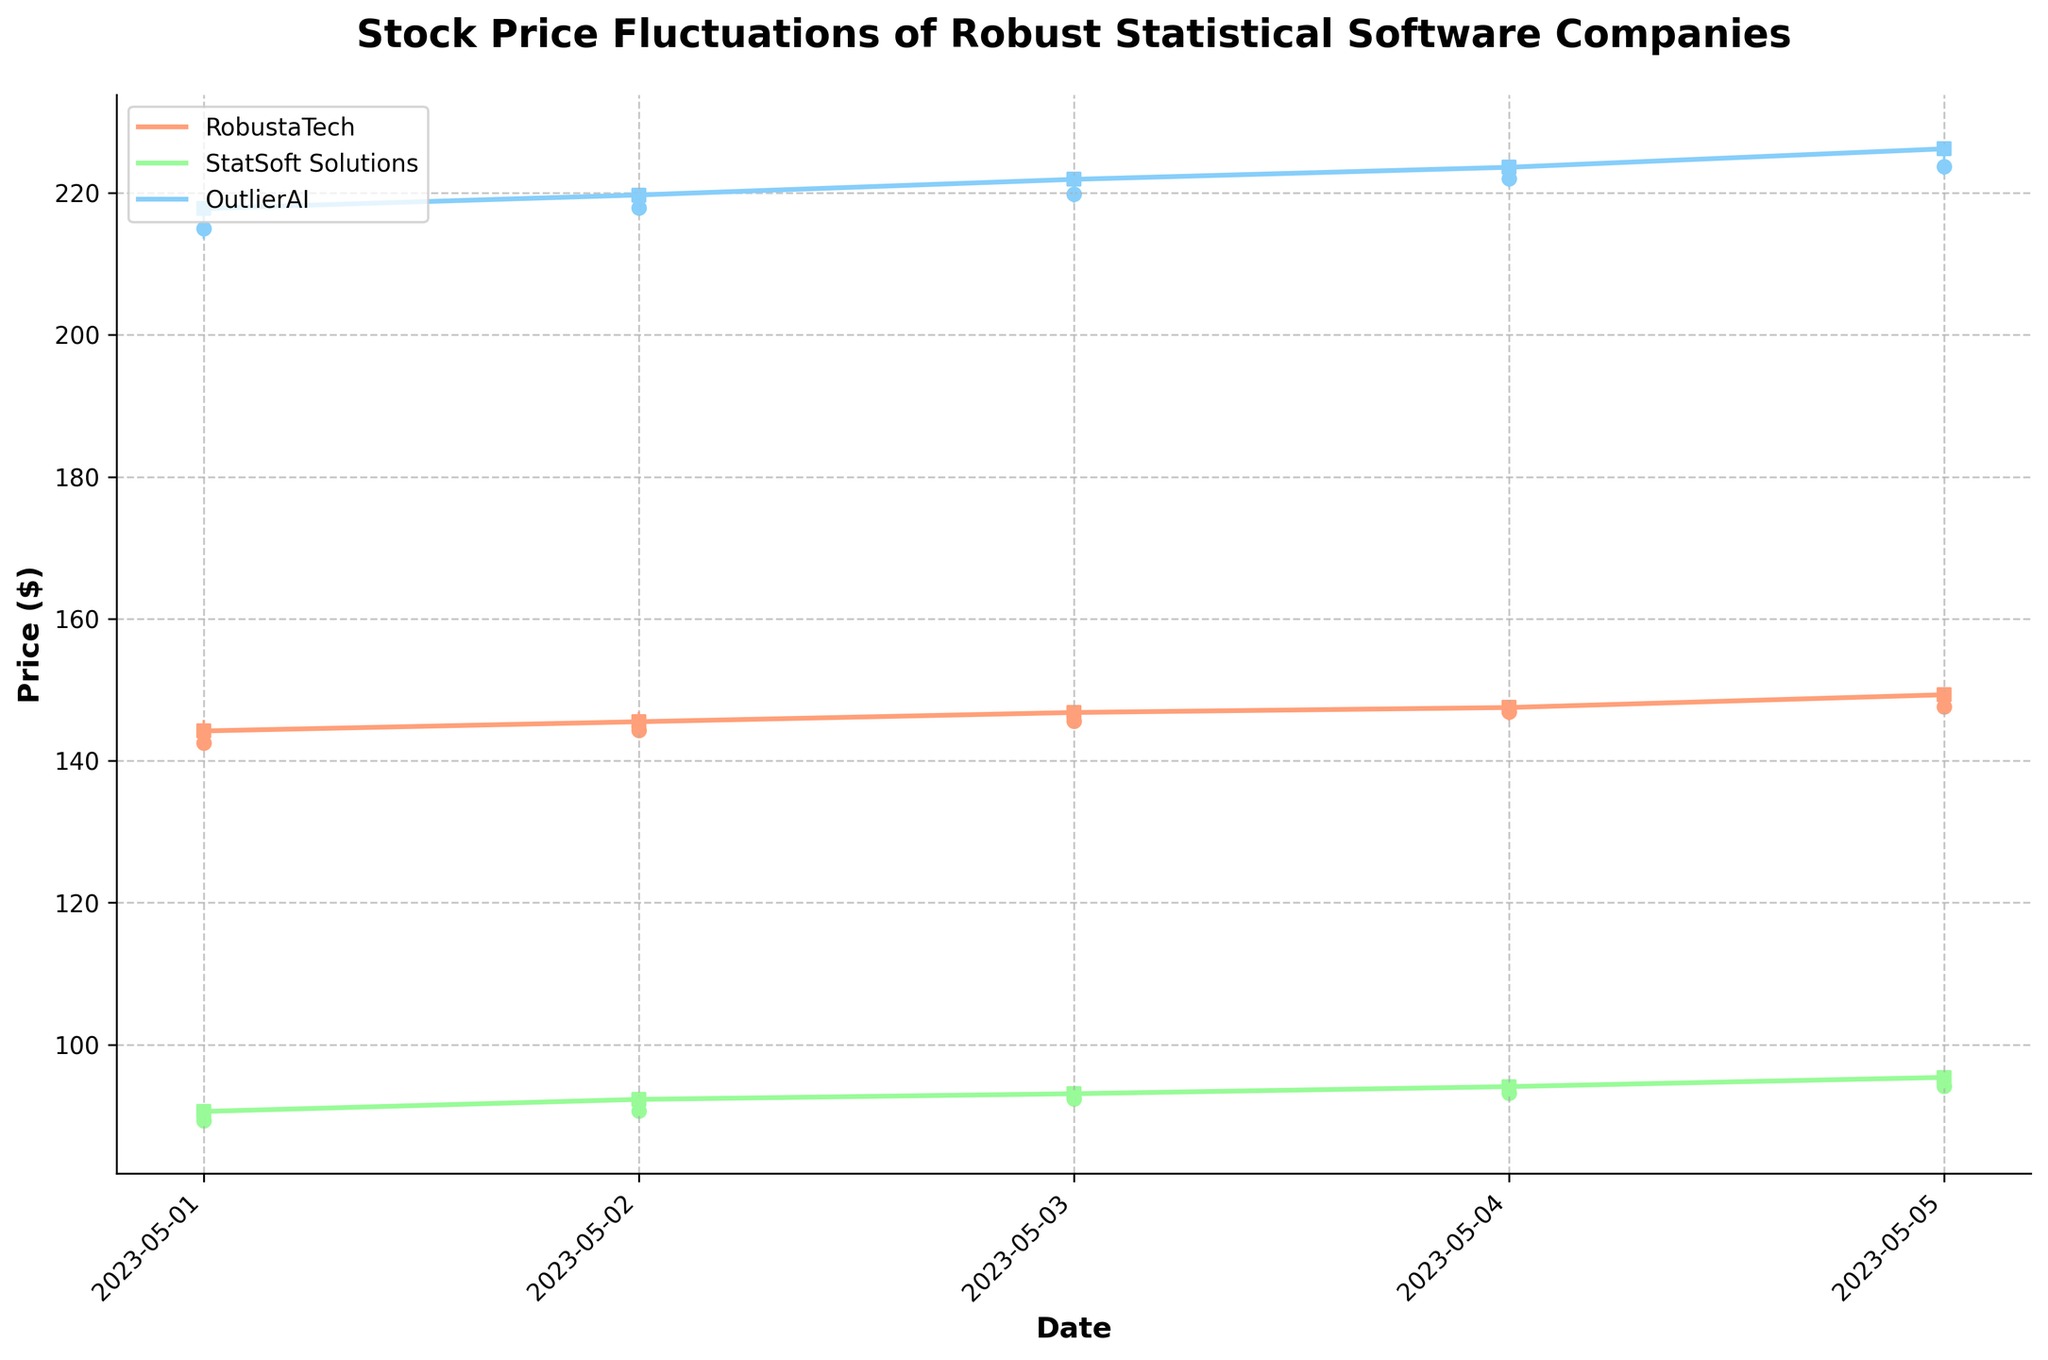what is the title of the figure? The title of the figure is located at the top of the chart and reads "Stock Price Fluctuations of Robust Statistical Software Companies".
Answer: Stock Price Fluctuations of Robust Statistical Software Companies What is the date range displayed in the chart? The date range is visible along the x-axis and spans from 2023-05-01 to 2023-05-05.
Answer: 2023-05-01 to 2023-05-05 Which company had the highest closing price on 2023-05-01? By looking at the close prices for each company on 2023-05-01, we see that OutlierAI had the highest closing price of $217.80.
Answer: OutlierAI Comparing the closing prices, which company showed the most increase from 2023-05-01 to 2023-05-05? To determine this, we look at the closing prices on these two dates for each company: RobustaTech increased from $144.20 to $149.30, StatSoft Solutions increased from $90.60 to $95.40, and OutlierAI increased from $217.80 to $226.20. OutlierAI showed the most increase.
Answer: OutlierAI Which company had the lowest high price on 2023-05-05? Looking at the high prices on 2023-05-05, the lowest high price was StatSoft Solutions at $95.70.
Answer: StatSoft Solutions What can you infer about the trend of StatSoft Solutions' stock from the chart? By observing the dates on the x-axis and the corresponding closing prices, we see an upward trend from $90.60 on 2023-05-01 to $95.40 on 2023-05-05. This indicates a gradual increase in the stock price over these days.
Answer: Upward trend Based on the chart, on which date did RobustaTech have the smallest range between its high and low prices? We can find this by comparing the ranges (high - low) for RobustaTech across the dates: 
2023-05-01: 145.75 - 141.80 = 3.95
2023-05-02: 146.90 - 143.75 = 3.15
2023-05-03: 147.20 - 144.90 = 2.30
2023-05-04: 148.30 - 145.70 = 2.60
2023-05-05: 149.80 - 146.90 = 2.90
The smallest range is on 2023-05-03 with a difference of 2.30.
Answer: 2023-05-03 On what date did OutlierAI reach its highest closing price in the given period? By examining the closing prices for OutlierAI each day, we see the highest closing price was $226.20 on 2023-05-05.
Answer: 2023-05-05 What is the color used to represent StatSoft Solutions in the chart? StatSoft Solutions is represented by a green color in the OHLC chart.
Answer: Green 